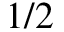<formula> <loc_0><loc_0><loc_500><loc_500>1 / 2</formula> 